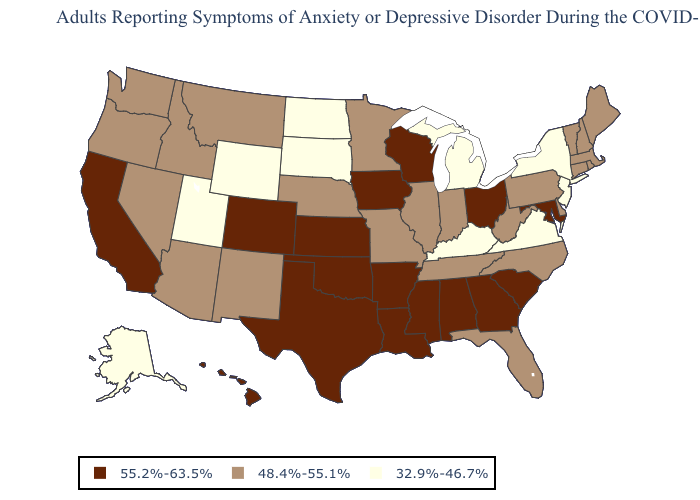Does Illinois have a higher value than Massachusetts?
Quick response, please. No. Name the states that have a value in the range 48.4%-55.1%?
Short answer required. Arizona, Connecticut, Delaware, Florida, Idaho, Illinois, Indiana, Maine, Massachusetts, Minnesota, Missouri, Montana, Nebraska, Nevada, New Hampshire, New Mexico, North Carolina, Oregon, Pennsylvania, Rhode Island, Tennessee, Vermont, Washington, West Virginia. What is the value of Washington?
Give a very brief answer. 48.4%-55.1%. What is the lowest value in states that border Minnesota?
Keep it brief. 32.9%-46.7%. What is the value of Oregon?
Quick response, please. 48.4%-55.1%. Among the states that border Kentucky , which have the lowest value?
Give a very brief answer. Virginia. Among the states that border Montana , which have the highest value?
Give a very brief answer. Idaho. Among the states that border South Dakota , which have the highest value?
Write a very short answer. Iowa. Name the states that have a value in the range 55.2%-63.5%?
Answer briefly. Alabama, Arkansas, California, Colorado, Georgia, Hawaii, Iowa, Kansas, Louisiana, Maryland, Mississippi, Ohio, Oklahoma, South Carolina, Texas, Wisconsin. Which states have the highest value in the USA?
Concise answer only. Alabama, Arkansas, California, Colorado, Georgia, Hawaii, Iowa, Kansas, Louisiana, Maryland, Mississippi, Ohio, Oklahoma, South Carolina, Texas, Wisconsin. Does Oregon have a lower value than Arkansas?
Give a very brief answer. Yes. Does Delaware have the same value as Oregon?
Quick response, please. Yes. Name the states that have a value in the range 32.9%-46.7%?
Quick response, please. Alaska, Kentucky, Michigan, New Jersey, New York, North Dakota, South Dakota, Utah, Virginia, Wyoming. Does the map have missing data?
Short answer required. No. What is the highest value in the USA?
Quick response, please. 55.2%-63.5%. 